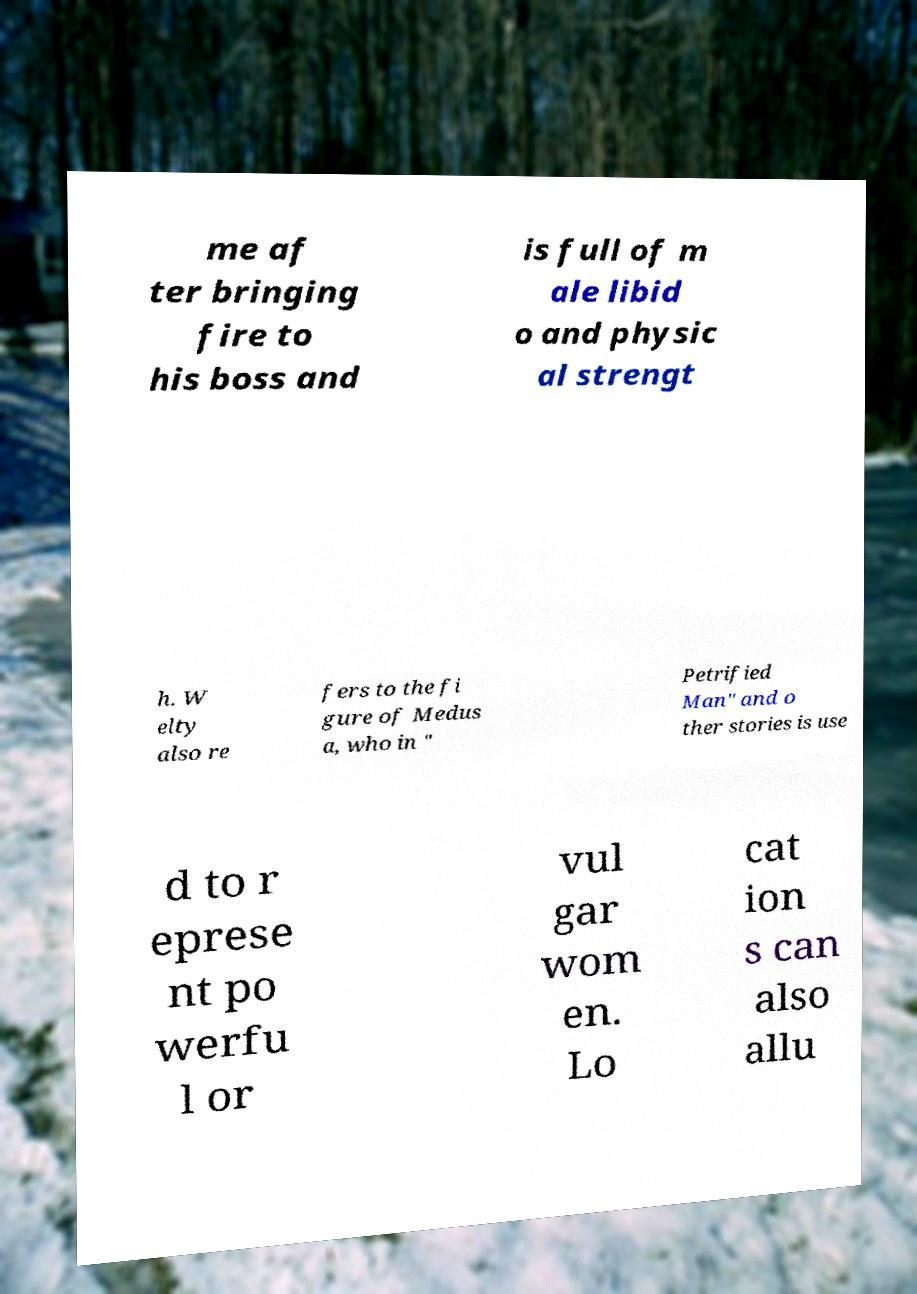What messages or text are displayed in this image? I need them in a readable, typed format. me af ter bringing fire to his boss and is full of m ale libid o and physic al strengt h. W elty also re fers to the fi gure of Medus a, who in " Petrified Man" and o ther stories is use d to r eprese nt po werfu l or vul gar wom en. Lo cat ion s can also allu 